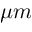<formula> <loc_0><loc_0><loc_500><loc_500>\mu m</formula> 